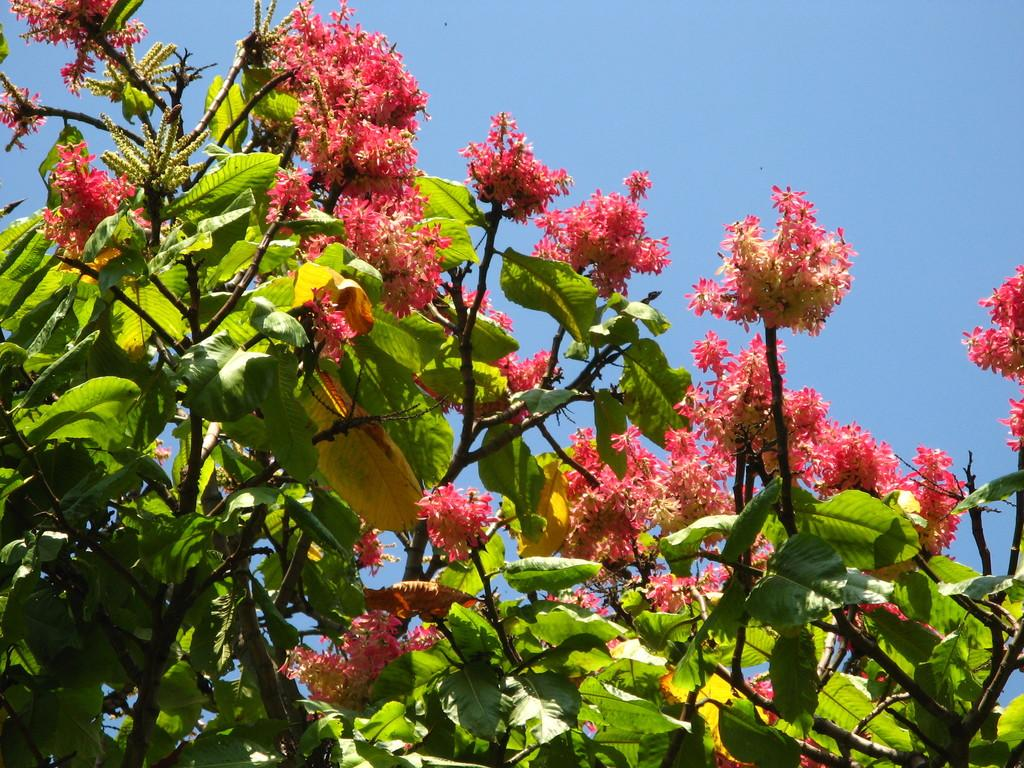What can be seen in the foreground of the picture? There are flowers, leaves, and stems of a tree in the foreground of the picture. What is the condition of the sky in the picture? The sky is clear in the picture. What is the weather like in the image? It is sunny in the image. What type of canvas is being used by the hands in the image? There are no hands or canvas present in the image; it features flowers, leaves, and tree stems in the foreground. What subject is being taught in the school depicted in the image? There is no school depicted in the image; it focuses on the foreground with flowers, leaves, and tree stems. 